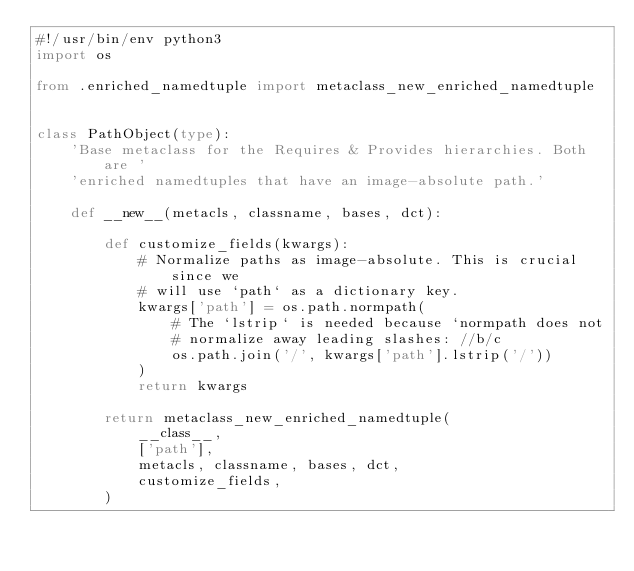<code> <loc_0><loc_0><loc_500><loc_500><_Python_>#!/usr/bin/env python3
import os

from .enriched_namedtuple import metaclass_new_enriched_namedtuple


class PathObject(type):
    'Base metaclass for the Requires & Provides hierarchies. Both are '
    'enriched namedtuples that have an image-absolute path.'

    def __new__(metacls, classname, bases, dct):

        def customize_fields(kwargs):
            # Normalize paths as image-absolute. This is crucial since we
            # will use `path` as a dictionary key.
            kwargs['path'] = os.path.normpath(
                # The `lstrip` is needed because `normpath does not
                # normalize away leading slashes: //b/c
                os.path.join('/', kwargs['path'].lstrip('/'))
            )
            return kwargs

        return metaclass_new_enriched_namedtuple(
            __class__,
            ['path'],
            metacls, classname, bases, dct,
            customize_fields,
        )
</code> 